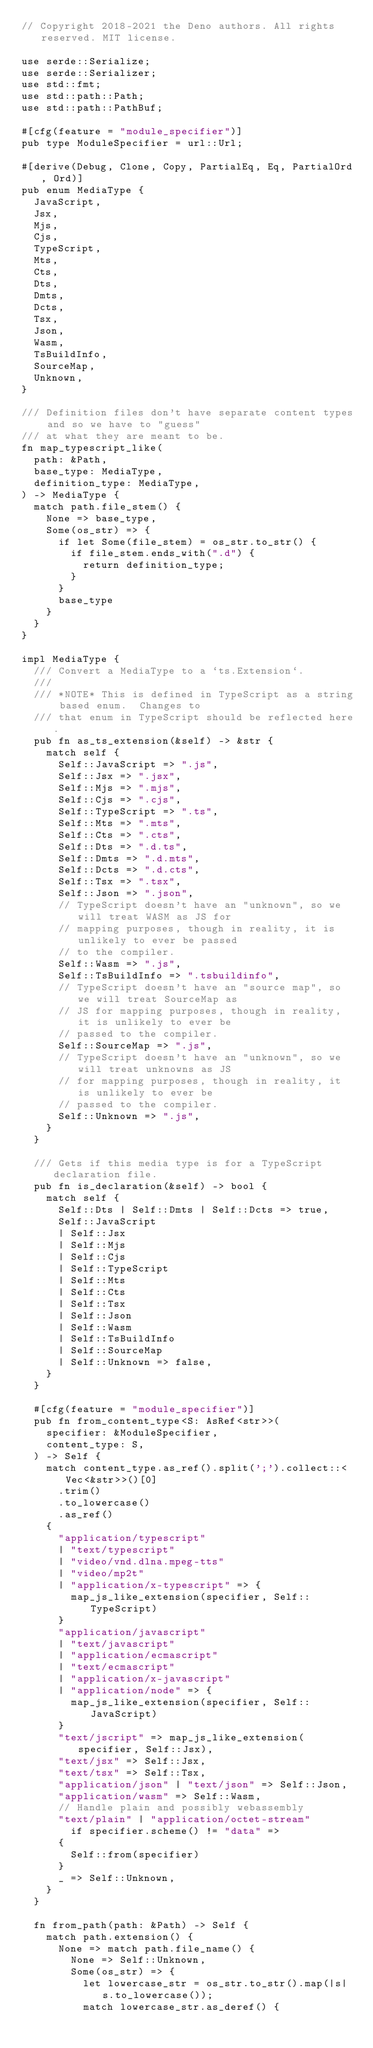Convert code to text. <code><loc_0><loc_0><loc_500><loc_500><_Rust_>// Copyright 2018-2021 the Deno authors. All rights reserved. MIT license.

use serde::Serialize;
use serde::Serializer;
use std::fmt;
use std::path::Path;
use std::path::PathBuf;

#[cfg(feature = "module_specifier")]
pub type ModuleSpecifier = url::Url;

#[derive(Debug, Clone, Copy, PartialEq, Eq, PartialOrd, Ord)]
pub enum MediaType {
  JavaScript,
  Jsx,
  Mjs,
  Cjs,
  TypeScript,
  Mts,
  Cts,
  Dts,
  Dmts,
  Dcts,
  Tsx,
  Json,
  Wasm,
  TsBuildInfo,
  SourceMap,
  Unknown,
}

/// Definition files don't have separate content types and so we have to "guess"
/// at what they are meant to be.
fn map_typescript_like(
  path: &Path,
  base_type: MediaType,
  definition_type: MediaType,
) -> MediaType {
  match path.file_stem() {
    None => base_type,
    Some(os_str) => {
      if let Some(file_stem) = os_str.to_str() {
        if file_stem.ends_with(".d") {
          return definition_type;
        }
      }
      base_type
    }
  }
}

impl MediaType {
  /// Convert a MediaType to a `ts.Extension`.
  ///
  /// *NOTE* This is defined in TypeScript as a string based enum.  Changes to
  /// that enum in TypeScript should be reflected here.
  pub fn as_ts_extension(&self) -> &str {
    match self {
      Self::JavaScript => ".js",
      Self::Jsx => ".jsx",
      Self::Mjs => ".mjs",
      Self::Cjs => ".cjs",
      Self::TypeScript => ".ts",
      Self::Mts => ".mts",
      Self::Cts => ".cts",
      Self::Dts => ".d.ts",
      Self::Dmts => ".d.mts",
      Self::Dcts => ".d.cts",
      Self::Tsx => ".tsx",
      Self::Json => ".json",
      // TypeScript doesn't have an "unknown", so we will treat WASM as JS for
      // mapping purposes, though in reality, it is unlikely to ever be passed
      // to the compiler.
      Self::Wasm => ".js",
      Self::TsBuildInfo => ".tsbuildinfo",
      // TypeScript doesn't have an "source map", so we will treat SourceMap as
      // JS for mapping purposes, though in reality, it is unlikely to ever be
      // passed to the compiler.
      Self::SourceMap => ".js",
      // TypeScript doesn't have an "unknown", so we will treat unknowns as JS
      // for mapping purposes, though in reality, it is unlikely to ever be
      // passed to the compiler.
      Self::Unknown => ".js",
    }
  }

  /// Gets if this media type is for a TypeScript declaration file.
  pub fn is_declaration(&self) -> bool {
    match self {
      Self::Dts | Self::Dmts | Self::Dcts => true,
      Self::JavaScript
      | Self::Jsx
      | Self::Mjs
      | Self::Cjs
      | Self::TypeScript
      | Self::Mts
      | Self::Cts
      | Self::Tsx
      | Self::Json
      | Self::Wasm
      | Self::TsBuildInfo
      | Self::SourceMap
      | Self::Unknown => false,
    }
  }

  #[cfg(feature = "module_specifier")]
  pub fn from_content_type<S: AsRef<str>>(
    specifier: &ModuleSpecifier,
    content_type: S,
  ) -> Self {
    match content_type.as_ref().split(';').collect::<Vec<&str>>()[0]
      .trim()
      .to_lowercase()
      .as_ref()
    {
      "application/typescript"
      | "text/typescript"
      | "video/vnd.dlna.mpeg-tts"
      | "video/mp2t"
      | "application/x-typescript" => {
        map_js_like_extension(specifier, Self::TypeScript)
      }
      "application/javascript"
      | "text/javascript"
      | "application/ecmascript"
      | "text/ecmascript"
      | "application/x-javascript"
      | "application/node" => {
        map_js_like_extension(specifier, Self::JavaScript)
      }
      "text/jscript" => map_js_like_extension(specifier, Self::Jsx),
      "text/jsx" => Self::Jsx,
      "text/tsx" => Self::Tsx,
      "application/json" | "text/json" => Self::Json,
      "application/wasm" => Self::Wasm,
      // Handle plain and possibly webassembly
      "text/plain" | "application/octet-stream"
        if specifier.scheme() != "data" =>
      {
        Self::from(specifier)
      }
      _ => Self::Unknown,
    }
  }

  fn from_path(path: &Path) -> Self {
    match path.extension() {
      None => match path.file_name() {
        None => Self::Unknown,
        Some(os_str) => {
          let lowercase_str = os_str.to_str().map(|s| s.to_lowercase());
          match lowercase_str.as_deref() {</code> 